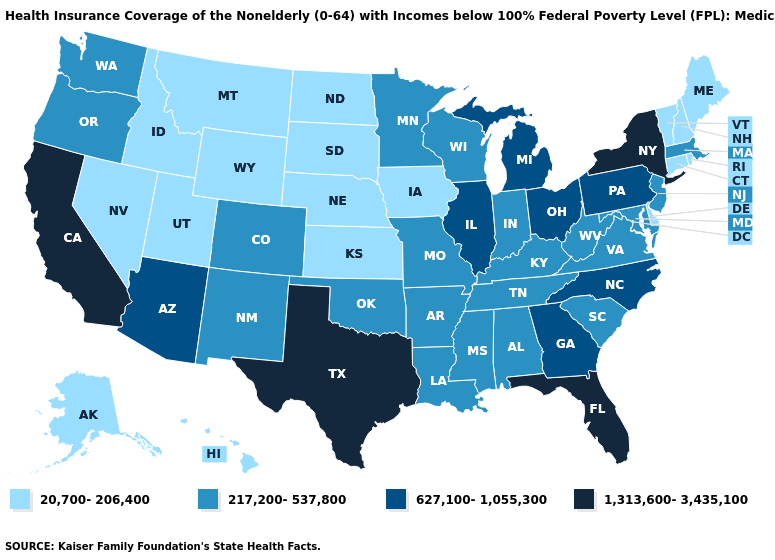What is the highest value in the West ?
Keep it brief. 1,313,600-3,435,100. Does Connecticut have a lower value than Mississippi?
Short answer required. Yes. Name the states that have a value in the range 1,313,600-3,435,100?
Short answer required. California, Florida, New York, Texas. Name the states that have a value in the range 217,200-537,800?
Write a very short answer. Alabama, Arkansas, Colorado, Indiana, Kentucky, Louisiana, Maryland, Massachusetts, Minnesota, Mississippi, Missouri, New Jersey, New Mexico, Oklahoma, Oregon, South Carolina, Tennessee, Virginia, Washington, West Virginia, Wisconsin. Which states have the lowest value in the South?
Short answer required. Delaware. What is the value of Minnesota?
Be succinct. 217,200-537,800. What is the value of New Jersey?
Answer briefly. 217,200-537,800. Which states have the lowest value in the West?
Be succinct. Alaska, Hawaii, Idaho, Montana, Nevada, Utah, Wyoming. Does Florida have the highest value in the USA?
Concise answer only. Yes. What is the value of New Hampshire?
Answer briefly. 20,700-206,400. What is the value of New Mexico?
Write a very short answer. 217,200-537,800. What is the value of Iowa?
Quick response, please. 20,700-206,400. Which states have the highest value in the USA?
Short answer required. California, Florida, New York, Texas. How many symbols are there in the legend?
Answer briefly. 4. Name the states that have a value in the range 1,313,600-3,435,100?
Write a very short answer. California, Florida, New York, Texas. 